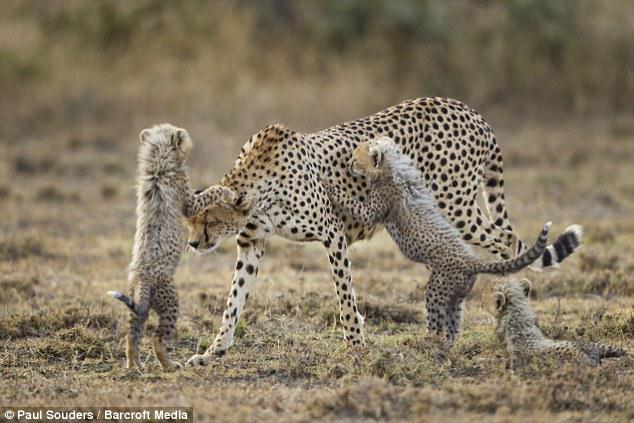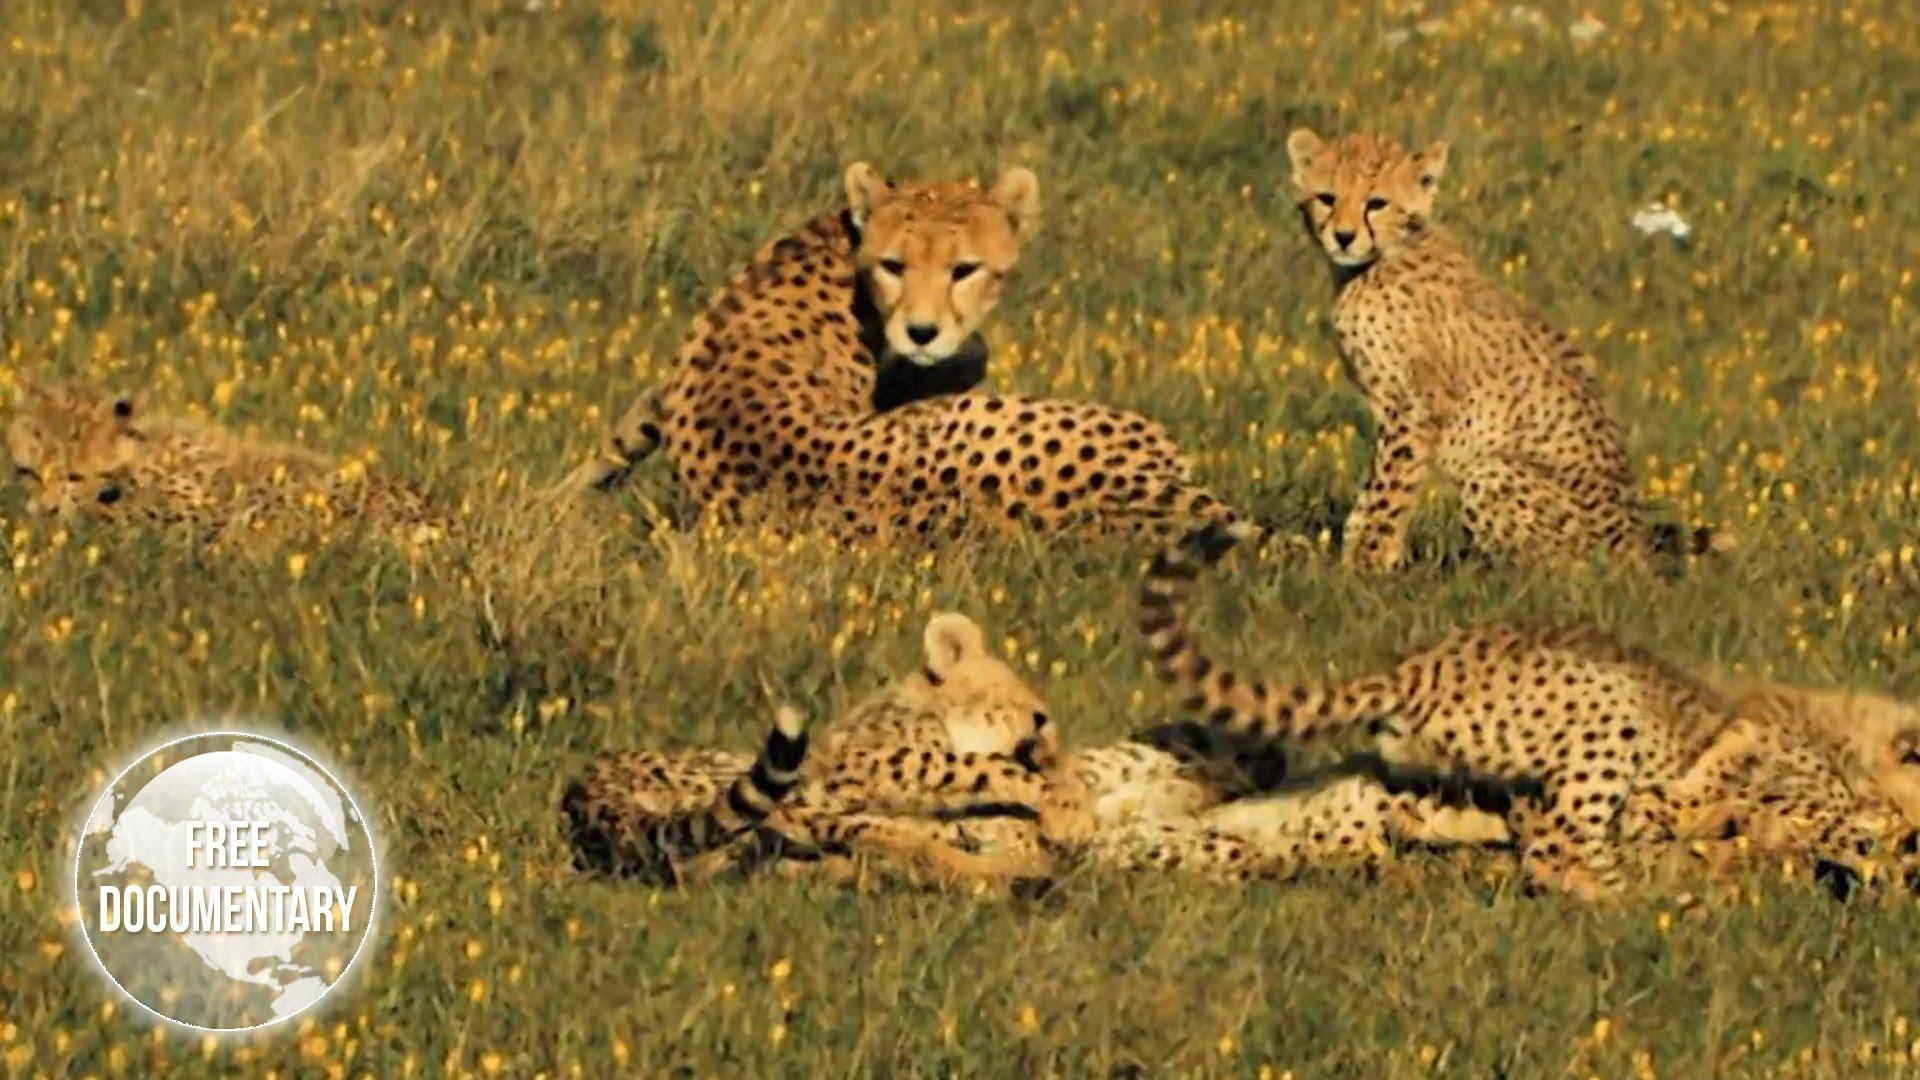The first image is the image on the left, the second image is the image on the right. Given the left and right images, does the statement "There are at most 4 cheetahs." hold true? Answer yes or no. No. The first image is the image on the left, the second image is the image on the right. Considering the images on both sides, is "One image has a wild cat in the middle of pouncing onto another wild cat." valid? Answer yes or no. No. 